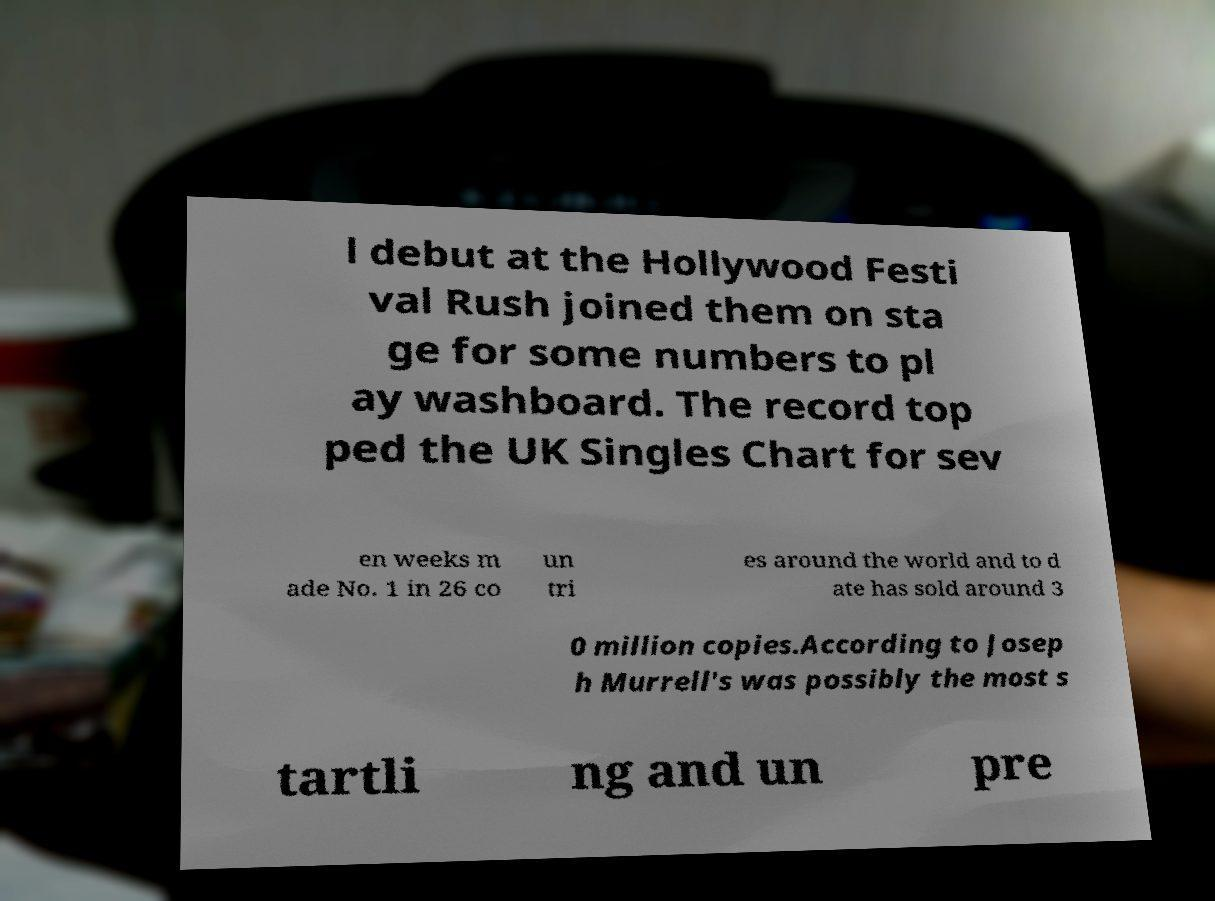Can you accurately transcribe the text from the provided image for me? l debut at the Hollywood Festi val Rush joined them on sta ge for some numbers to pl ay washboard. The record top ped the UK Singles Chart for sev en weeks m ade No. 1 in 26 co un tri es around the world and to d ate has sold around 3 0 million copies.According to Josep h Murrell's was possibly the most s tartli ng and un pre 